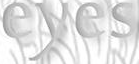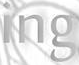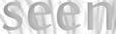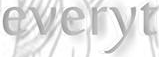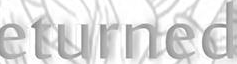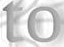What text is displayed in these images sequentially, separated by a semicolon? eyes; ing; seen; everyt; eturned; to 